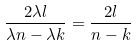<formula> <loc_0><loc_0><loc_500><loc_500>\frac { 2 \lambda l } { \lambda n - \lambda k } = \frac { 2 l } { n - k }</formula> 